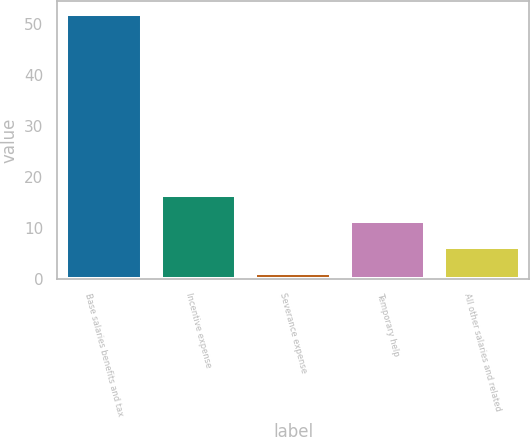Convert chart to OTSL. <chart><loc_0><loc_0><loc_500><loc_500><bar_chart><fcel>Base salaries benefits and tax<fcel>Incentive expense<fcel>Severance expense<fcel>Temporary help<fcel>All other salaries and related<nl><fcel>51.9<fcel>16.41<fcel>1.2<fcel>11.34<fcel>6.27<nl></chart> 